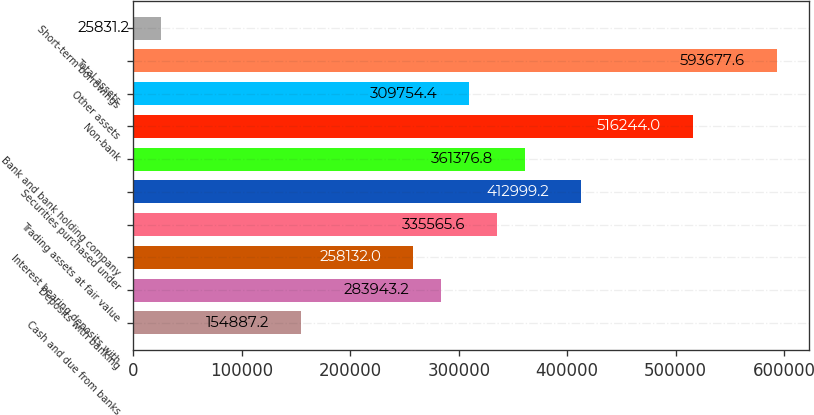Convert chart. <chart><loc_0><loc_0><loc_500><loc_500><bar_chart><fcel>Cash and due from banks<fcel>Deposits with banking<fcel>Interest bearing deposits with<fcel>Trading assets at fair value<fcel>Securities purchased under<fcel>Bank and bank holding company<fcel>Non-bank<fcel>Other assets<fcel>Total assets<fcel>Short-term borrowings<nl><fcel>154887<fcel>283943<fcel>258132<fcel>335566<fcel>412999<fcel>361377<fcel>516244<fcel>309754<fcel>593678<fcel>25831.2<nl></chart> 